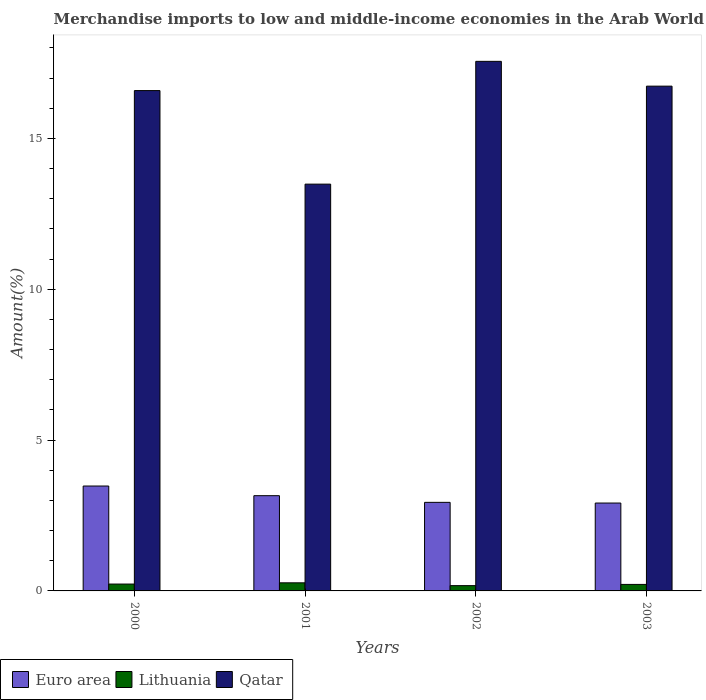How many groups of bars are there?
Your answer should be very brief. 4. Are the number of bars on each tick of the X-axis equal?
Provide a succinct answer. Yes. What is the label of the 2nd group of bars from the left?
Offer a terse response. 2001. What is the percentage of amount earned from merchandise imports in Qatar in 2002?
Your response must be concise. 17.56. Across all years, what is the maximum percentage of amount earned from merchandise imports in Euro area?
Provide a short and direct response. 3.48. Across all years, what is the minimum percentage of amount earned from merchandise imports in Euro area?
Your answer should be very brief. 2.91. In which year was the percentage of amount earned from merchandise imports in Euro area minimum?
Your response must be concise. 2003. What is the total percentage of amount earned from merchandise imports in Euro area in the graph?
Ensure brevity in your answer.  12.48. What is the difference between the percentage of amount earned from merchandise imports in Euro area in 2000 and that in 2001?
Ensure brevity in your answer.  0.32. What is the difference between the percentage of amount earned from merchandise imports in Lithuania in 2000 and the percentage of amount earned from merchandise imports in Euro area in 2002?
Offer a terse response. -2.71. What is the average percentage of amount earned from merchandise imports in Euro area per year?
Offer a terse response. 3.12. In the year 2002, what is the difference between the percentage of amount earned from merchandise imports in Lithuania and percentage of amount earned from merchandise imports in Qatar?
Provide a succinct answer. -17.38. What is the ratio of the percentage of amount earned from merchandise imports in Euro area in 2001 to that in 2002?
Offer a very short reply. 1.08. Is the percentage of amount earned from merchandise imports in Euro area in 2001 less than that in 2002?
Make the answer very short. No. Is the difference between the percentage of amount earned from merchandise imports in Lithuania in 2000 and 2001 greater than the difference between the percentage of amount earned from merchandise imports in Qatar in 2000 and 2001?
Offer a very short reply. No. What is the difference between the highest and the second highest percentage of amount earned from merchandise imports in Qatar?
Provide a short and direct response. 0.82. What is the difference between the highest and the lowest percentage of amount earned from merchandise imports in Qatar?
Your response must be concise. 4.07. In how many years, is the percentage of amount earned from merchandise imports in Qatar greater than the average percentage of amount earned from merchandise imports in Qatar taken over all years?
Your response must be concise. 3. Is the sum of the percentage of amount earned from merchandise imports in Euro area in 2000 and 2001 greater than the maximum percentage of amount earned from merchandise imports in Lithuania across all years?
Keep it short and to the point. Yes. What does the 2nd bar from the left in 2003 represents?
Keep it short and to the point. Lithuania. What does the 1st bar from the right in 2003 represents?
Ensure brevity in your answer.  Qatar. Is it the case that in every year, the sum of the percentage of amount earned from merchandise imports in Euro area and percentage of amount earned from merchandise imports in Qatar is greater than the percentage of amount earned from merchandise imports in Lithuania?
Keep it short and to the point. Yes. Are all the bars in the graph horizontal?
Your answer should be compact. No. What is the difference between two consecutive major ticks on the Y-axis?
Make the answer very short. 5. Are the values on the major ticks of Y-axis written in scientific E-notation?
Your answer should be compact. No. Does the graph contain any zero values?
Your answer should be very brief. No. Where does the legend appear in the graph?
Offer a terse response. Bottom left. What is the title of the graph?
Your answer should be very brief. Merchandise imports to low and middle-income economies in the Arab World. What is the label or title of the X-axis?
Offer a very short reply. Years. What is the label or title of the Y-axis?
Provide a short and direct response. Amount(%). What is the Amount(%) in Euro area in 2000?
Provide a short and direct response. 3.48. What is the Amount(%) of Lithuania in 2000?
Provide a short and direct response. 0.23. What is the Amount(%) in Qatar in 2000?
Your answer should be compact. 16.59. What is the Amount(%) in Euro area in 2001?
Keep it short and to the point. 3.16. What is the Amount(%) in Lithuania in 2001?
Provide a short and direct response. 0.27. What is the Amount(%) of Qatar in 2001?
Make the answer very short. 13.49. What is the Amount(%) in Euro area in 2002?
Ensure brevity in your answer.  2.94. What is the Amount(%) in Lithuania in 2002?
Provide a short and direct response. 0.18. What is the Amount(%) in Qatar in 2002?
Offer a terse response. 17.56. What is the Amount(%) of Euro area in 2003?
Offer a very short reply. 2.91. What is the Amount(%) of Lithuania in 2003?
Your answer should be compact. 0.22. What is the Amount(%) of Qatar in 2003?
Your answer should be very brief. 16.73. Across all years, what is the maximum Amount(%) in Euro area?
Ensure brevity in your answer.  3.48. Across all years, what is the maximum Amount(%) in Lithuania?
Offer a terse response. 0.27. Across all years, what is the maximum Amount(%) in Qatar?
Provide a succinct answer. 17.56. Across all years, what is the minimum Amount(%) of Euro area?
Ensure brevity in your answer.  2.91. Across all years, what is the minimum Amount(%) in Lithuania?
Provide a short and direct response. 0.18. Across all years, what is the minimum Amount(%) in Qatar?
Offer a very short reply. 13.49. What is the total Amount(%) in Euro area in the graph?
Give a very brief answer. 12.48. What is the total Amount(%) of Lithuania in the graph?
Your response must be concise. 0.89. What is the total Amount(%) in Qatar in the graph?
Give a very brief answer. 64.36. What is the difference between the Amount(%) of Euro area in 2000 and that in 2001?
Keep it short and to the point. 0.32. What is the difference between the Amount(%) in Lithuania in 2000 and that in 2001?
Your answer should be very brief. -0.04. What is the difference between the Amount(%) in Qatar in 2000 and that in 2001?
Offer a very short reply. 3.1. What is the difference between the Amount(%) in Euro area in 2000 and that in 2002?
Ensure brevity in your answer.  0.54. What is the difference between the Amount(%) of Lithuania in 2000 and that in 2002?
Your answer should be very brief. 0.05. What is the difference between the Amount(%) of Qatar in 2000 and that in 2002?
Ensure brevity in your answer.  -0.97. What is the difference between the Amount(%) in Euro area in 2000 and that in 2003?
Give a very brief answer. 0.56. What is the difference between the Amount(%) of Lithuania in 2000 and that in 2003?
Make the answer very short. 0.01. What is the difference between the Amount(%) in Qatar in 2000 and that in 2003?
Give a very brief answer. -0.15. What is the difference between the Amount(%) in Euro area in 2001 and that in 2002?
Offer a terse response. 0.22. What is the difference between the Amount(%) of Lithuania in 2001 and that in 2002?
Give a very brief answer. 0.09. What is the difference between the Amount(%) of Qatar in 2001 and that in 2002?
Keep it short and to the point. -4.07. What is the difference between the Amount(%) in Euro area in 2001 and that in 2003?
Offer a terse response. 0.24. What is the difference between the Amount(%) in Lithuania in 2001 and that in 2003?
Offer a terse response. 0.05. What is the difference between the Amount(%) in Qatar in 2001 and that in 2003?
Your answer should be very brief. -3.25. What is the difference between the Amount(%) in Euro area in 2002 and that in 2003?
Provide a succinct answer. 0.02. What is the difference between the Amount(%) of Lithuania in 2002 and that in 2003?
Offer a terse response. -0.04. What is the difference between the Amount(%) in Qatar in 2002 and that in 2003?
Make the answer very short. 0.82. What is the difference between the Amount(%) of Euro area in 2000 and the Amount(%) of Lithuania in 2001?
Provide a succinct answer. 3.21. What is the difference between the Amount(%) of Euro area in 2000 and the Amount(%) of Qatar in 2001?
Your answer should be very brief. -10.01. What is the difference between the Amount(%) in Lithuania in 2000 and the Amount(%) in Qatar in 2001?
Offer a terse response. -13.26. What is the difference between the Amount(%) in Euro area in 2000 and the Amount(%) in Lithuania in 2002?
Provide a short and direct response. 3.3. What is the difference between the Amount(%) of Euro area in 2000 and the Amount(%) of Qatar in 2002?
Keep it short and to the point. -14.08. What is the difference between the Amount(%) in Lithuania in 2000 and the Amount(%) in Qatar in 2002?
Your answer should be compact. -17.33. What is the difference between the Amount(%) in Euro area in 2000 and the Amount(%) in Lithuania in 2003?
Ensure brevity in your answer.  3.26. What is the difference between the Amount(%) of Euro area in 2000 and the Amount(%) of Qatar in 2003?
Offer a terse response. -13.26. What is the difference between the Amount(%) in Lithuania in 2000 and the Amount(%) in Qatar in 2003?
Your response must be concise. -16.51. What is the difference between the Amount(%) in Euro area in 2001 and the Amount(%) in Lithuania in 2002?
Your answer should be very brief. 2.98. What is the difference between the Amount(%) in Euro area in 2001 and the Amount(%) in Qatar in 2002?
Your answer should be compact. -14.4. What is the difference between the Amount(%) of Lithuania in 2001 and the Amount(%) of Qatar in 2002?
Keep it short and to the point. -17.29. What is the difference between the Amount(%) in Euro area in 2001 and the Amount(%) in Lithuania in 2003?
Offer a very short reply. 2.94. What is the difference between the Amount(%) of Euro area in 2001 and the Amount(%) of Qatar in 2003?
Offer a terse response. -13.58. What is the difference between the Amount(%) of Lithuania in 2001 and the Amount(%) of Qatar in 2003?
Ensure brevity in your answer.  -16.47. What is the difference between the Amount(%) in Euro area in 2002 and the Amount(%) in Lithuania in 2003?
Keep it short and to the point. 2.72. What is the difference between the Amount(%) of Euro area in 2002 and the Amount(%) of Qatar in 2003?
Your answer should be compact. -13.8. What is the difference between the Amount(%) of Lithuania in 2002 and the Amount(%) of Qatar in 2003?
Your answer should be very brief. -16.56. What is the average Amount(%) of Euro area per year?
Provide a short and direct response. 3.12. What is the average Amount(%) of Lithuania per year?
Provide a succinct answer. 0.22. What is the average Amount(%) of Qatar per year?
Your answer should be compact. 16.09. In the year 2000, what is the difference between the Amount(%) of Euro area and Amount(%) of Lithuania?
Your answer should be very brief. 3.25. In the year 2000, what is the difference between the Amount(%) in Euro area and Amount(%) in Qatar?
Your answer should be compact. -13.11. In the year 2000, what is the difference between the Amount(%) in Lithuania and Amount(%) in Qatar?
Offer a very short reply. -16.36. In the year 2001, what is the difference between the Amount(%) of Euro area and Amount(%) of Lithuania?
Ensure brevity in your answer.  2.89. In the year 2001, what is the difference between the Amount(%) in Euro area and Amount(%) in Qatar?
Make the answer very short. -10.33. In the year 2001, what is the difference between the Amount(%) of Lithuania and Amount(%) of Qatar?
Provide a short and direct response. -13.22. In the year 2002, what is the difference between the Amount(%) of Euro area and Amount(%) of Lithuania?
Ensure brevity in your answer.  2.76. In the year 2002, what is the difference between the Amount(%) of Euro area and Amount(%) of Qatar?
Your answer should be very brief. -14.62. In the year 2002, what is the difference between the Amount(%) of Lithuania and Amount(%) of Qatar?
Provide a succinct answer. -17.38. In the year 2003, what is the difference between the Amount(%) in Euro area and Amount(%) in Lithuania?
Offer a terse response. 2.7. In the year 2003, what is the difference between the Amount(%) in Euro area and Amount(%) in Qatar?
Ensure brevity in your answer.  -13.82. In the year 2003, what is the difference between the Amount(%) of Lithuania and Amount(%) of Qatar?
Give a very brief answer. -16.52. What is the ratio of the Amount(%) in Euro area in 2000 to that in 2001?
Keep it short and to the point. 1.1. What is the ratio of the Amount(%) of Lithuania in 2000 to that in 2001?
Offer a very short reply. 0.85. What is the ratio of the Amount(%) of Qatar in 2000 to that in 2001?
Your response must be concise. 1.23. What is the ratio of the Amount(%) in Euro area in 2000 to that in 2002?
Give a very brief answer. 1.18. What is the ratio of the Amount(%) of Lithuania in 2000 to that in 2002?
Keep it short and to the point. 1.3. What is the ratio of the Amount(%) of Qatar in 2000 to that in 2002?
Ensure brevity in your answer.  0.94. What is the ratio of the Amount(%) in Euro area in 2000 to that in 2003?
Offer a very short reply. 1.19. What is the ratio of the Amount(%) in Lithuania in 2000 to that in 2003?
Provide a short and direct response. 1.06. What is the ratio of the Amount(%) of Euro area in 2001 to that in 2002?
Your answer should be compact. 1.08. What is the ratio of the Amount(%) of Lithuania in 2001 to that in 2002?
Ensure brevity in your answer.  1.53. What is the ratio of the Amount(%) in Qatar in 2001 to that in 2002?
Offer a terse response. 0.77. What is the ratio of the Amount(%) of Euro area in 2001 to that in 2003?
Provide a succinct answer. 1.08. What is the ratio of the Amount(%) of Lithuania in 2001 to that in 2003?
Offer a very short reply. 1.25. What is the ratio of the Amount(%) in Qatar in 2001 to that in 2003?
Offer a terse response. 0.81. What is the ratio of the Amount(%) in Euro area in 2002 to that in 2003?
Ensure brevity in your answer.  1.01. What is the ratio of the Amount(%) of Lithuania in 2002 to that in 2003?
Make the answer very short. 0.81. What is the ratio of the Amount(%) of Qatar in 2002 to that in 2003?
Give a very brief answer. 1.05. What is the difference between the highest and the second highest Amount(%) of Euro area?
Your answer should be compact. 0.32. What is the difference between the highest and the second highest Amount(%) of Lithuania?
Keep it short and to the point. 0.04. What is the difference between the highest and the second highest Amount(%) of Qatar?
Provide a succinct answer. 0.82. What is the difference between the highest and the lowest Amount(%) in Euro area?
Make the answer very short. 0.56. What is the difference between the highest and the lowest Amount(%) in Lithuania?
Give a very brief answer. 0.09. What is the difference between the highest and the lowest Amount(%) of Qatar?
Your answer should be very brief. 4.07. 